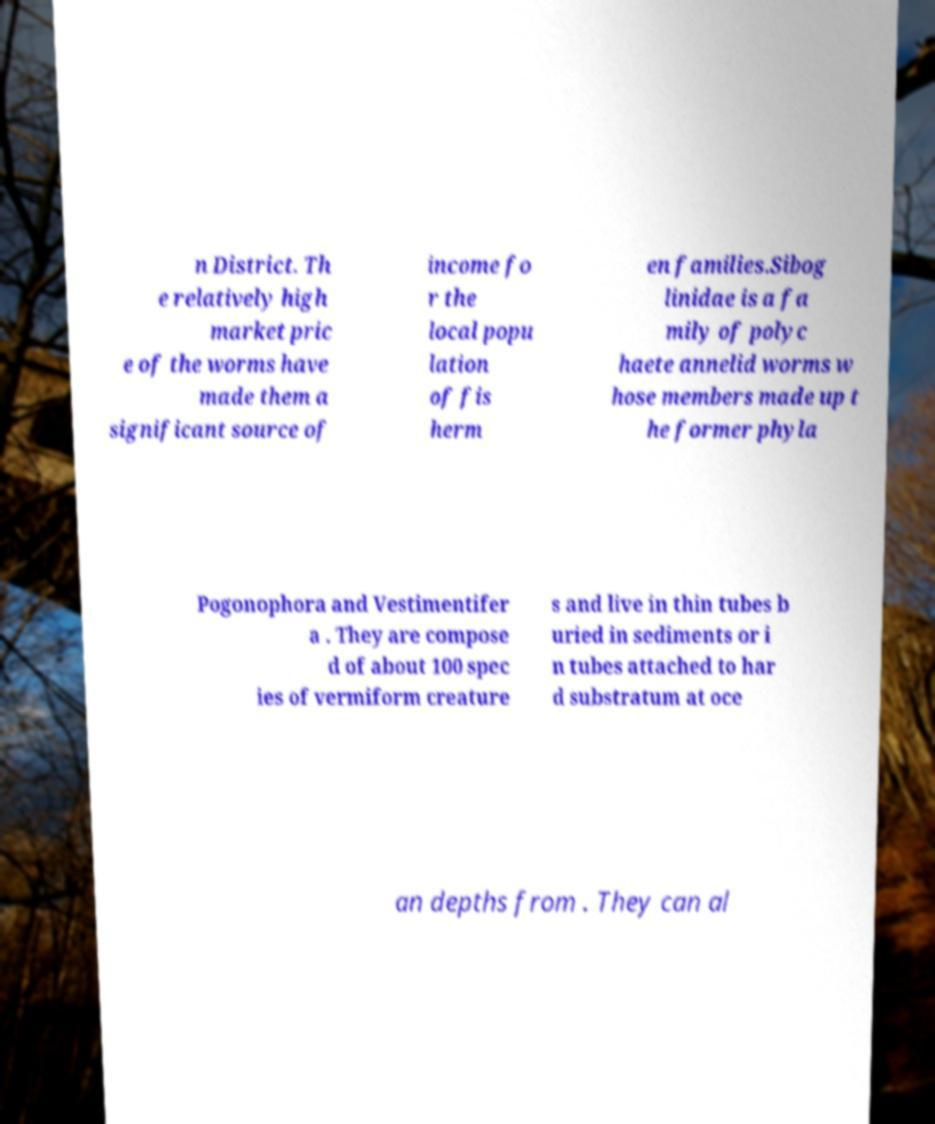Could you assist in decoding the text presented in this image and type it out clearly? n District. Th e relatively high market pric e of the worms have made them a significant source of income fo r the local popu lation of fis herm en families.Sibog linidae is a fa mily of polyc haete annelid worms w hose members made up t he former phyla Pogonophora and Vestimentifer a . They are compose d of about 100 spec ies of vermiform creature s and live in thin tubes b uried in sediments or i n tubes attached to har d substratum at oce an depths from . They can al 